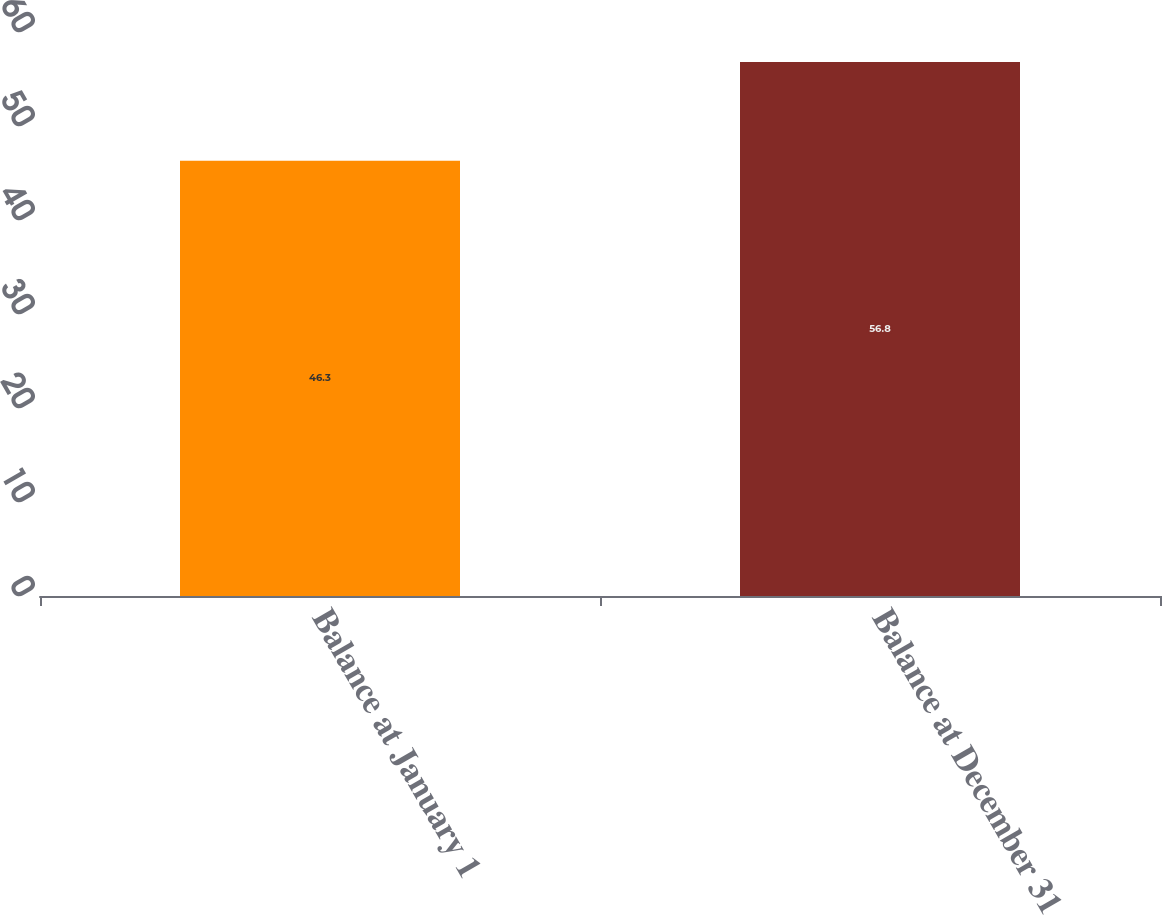Convert chart. <chart><loc_0><loc_0><loc_500><loc_500><bar_chart><fcel>Balance at January 1<fcel>Balance at December 31<nl><fcel>46.3<fcel>56.8<nl></chart> 